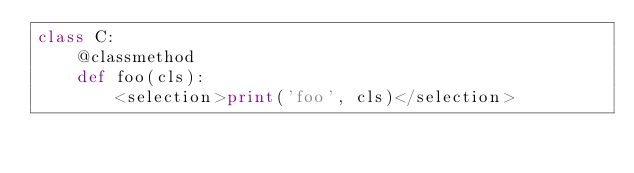Convert code to text. <code><loc_0><loc_0><loc_500><loc_500><_Python_>class C:
    @classmethod
    def foo(cls):
        <selection>print('foo', cls)</selection>
</code> 